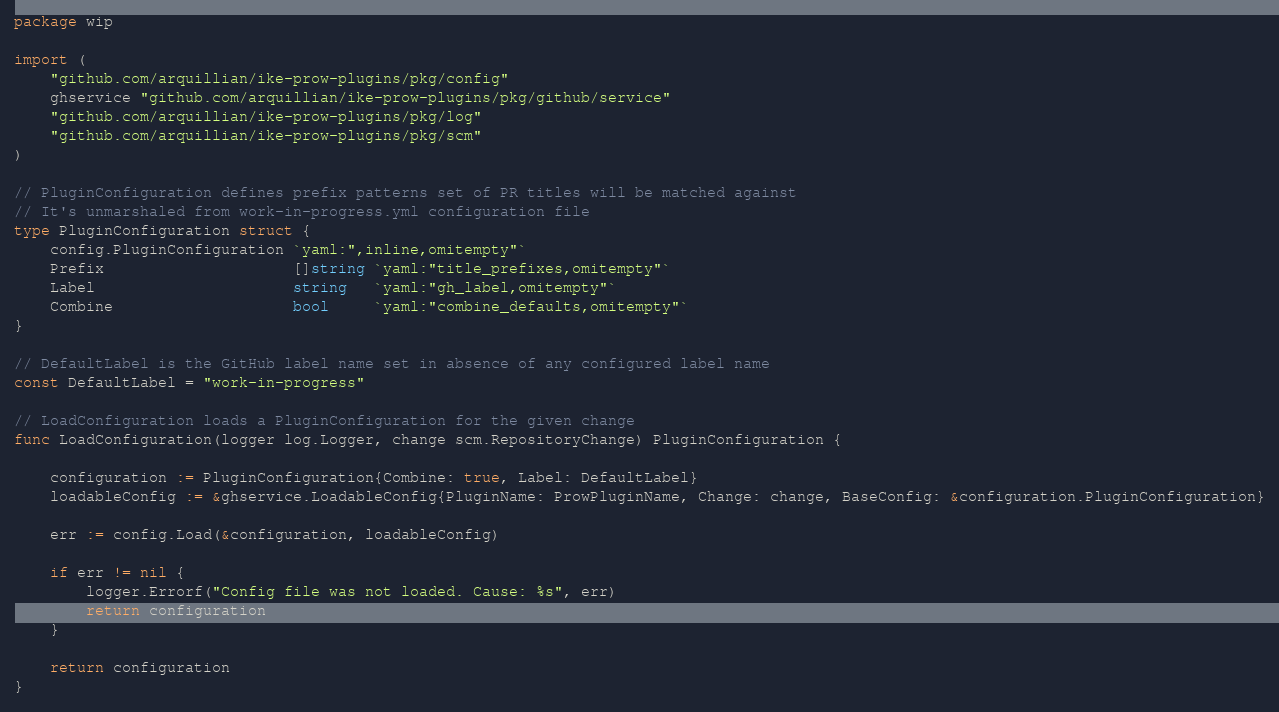<code> <loc_0><loc_0><loc_500><loc_500><_Go_>package wip

import (
	"github.com/arquillian/ike-prow-plugins/pkg/config"
	ghservice "github.com/arquillian/ike-prow-plugins/pkg/github/service"
	"github.com/arquillian/ike-prow-plugins/pkg/log"
	"github.com/arquillian/ike-prow-plugins/pkg/scm"
)

// PluginConfiguration defines prefix patterns set of PR titles will be matched against
// It's unmarshaled from work-in-progress.yml configuration file
type PluginConfiguration struct {
	config.PluginConfiguration `yaml:",inline,omitempty"`
	Prefix                     []string `yaml:"title_prefixes,omitempty"`
	Label                      string   `yaml:"gh_label,omitempty"`
	Combine                    bool     `yaml:"combine_defaults,omitempty"`
}

// DefaultLabel is the GitHub label name set in absence of any configured label name
const DefaultLabel = "work-in-progress"

// LoadConfiguration loads a PluginConfiguration for the given change
func LoadConfiguration(logger log.Logger, change scm.RepositoryChange) PluginConfiguration {

	configuration := PluginConfiguration{Combine: true, Label: DefaultLabel}
	loadableConfig := &ghservice.LoadableConfig{PluginName: ProwPluginName, Change: change, BaseConfig: &configuration.PluginConfiguration}

	err := config.Load(&configuration, loadableConfig)

	if err != nil {
		logger.Errorf("Config file was not loaded. Cause: %s", err)
		return configuration
	}

	return configuration
}
</code> 